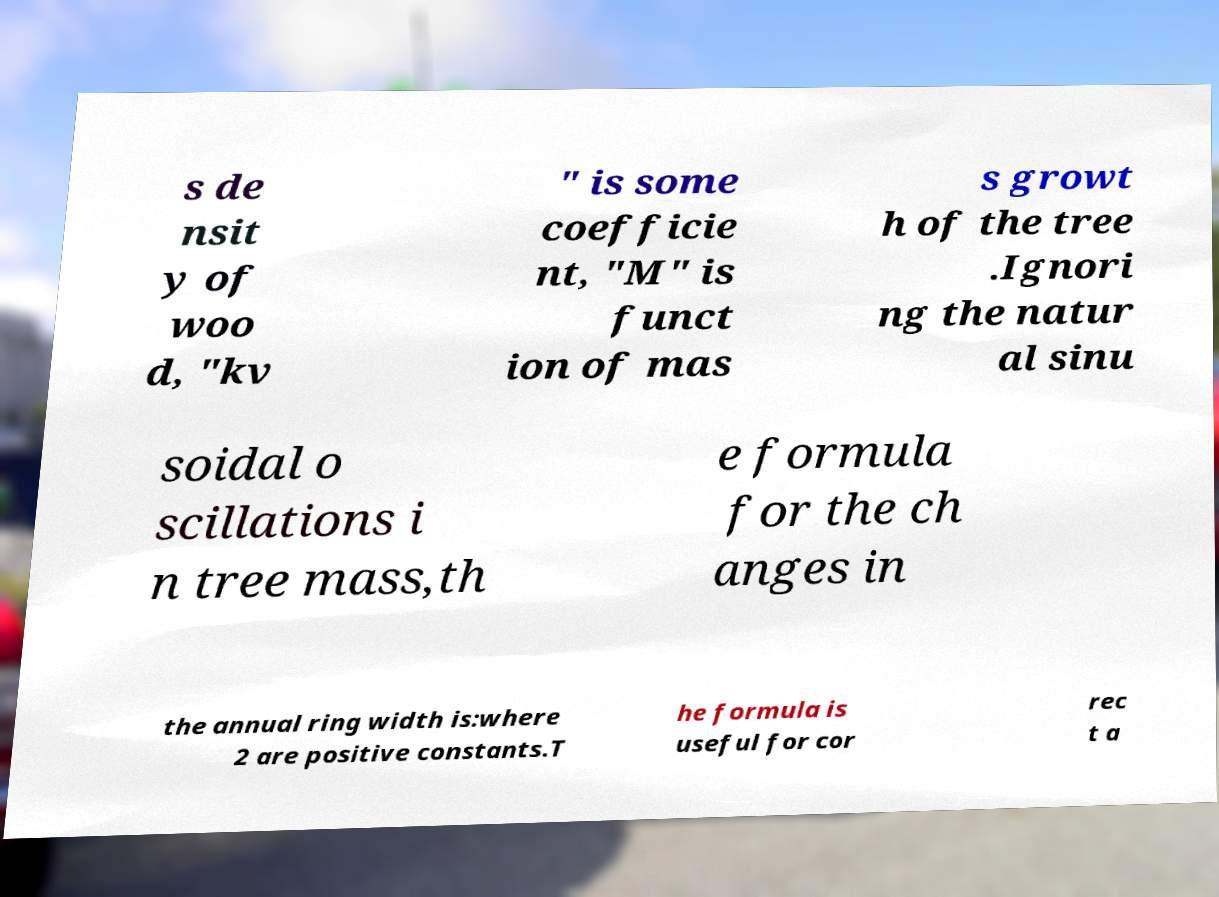What messages or text are displayed in this image? I need them in a readable, typed format. s de nsit y of woo d, "kv " is some coefficie nt, "M" is funct ion of mas s growt h of the tree .Ignori ng the natur al sinu soidal o scillations i n tree mass,th e formula for the ch anges in the annual ring width is:where 2 are positive constants.T he formula is useful for cor rec t a 